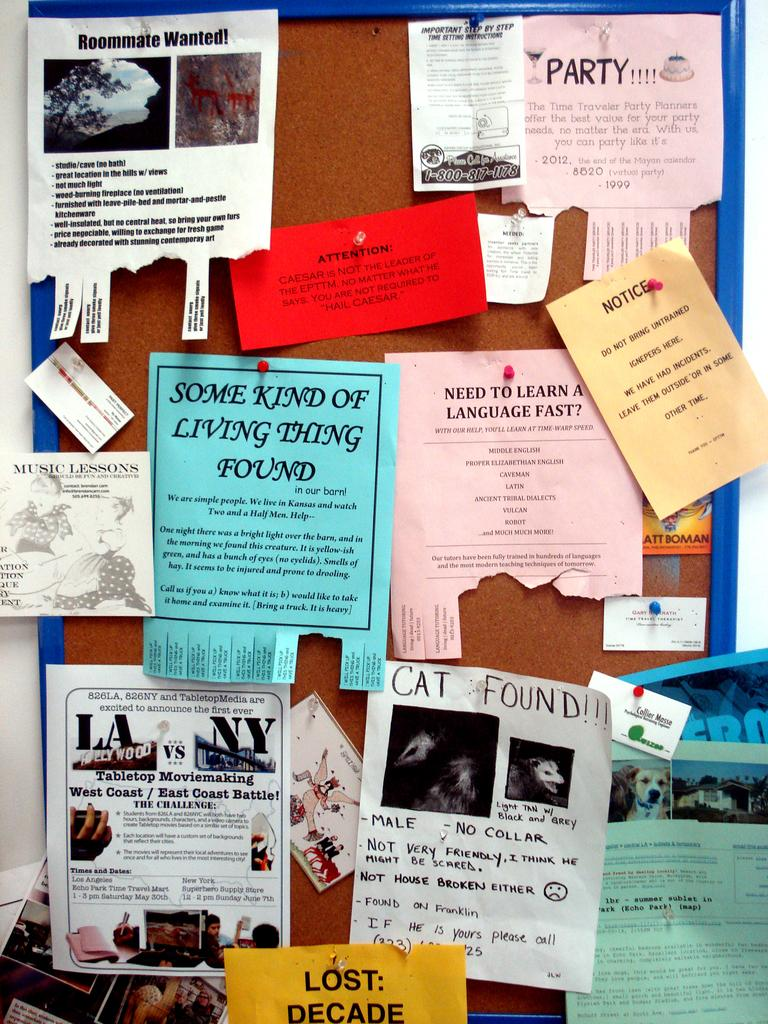<image>
Give a short and clear explanation of the subsequent image. Bulletin board with a paper that says "Some kind of living thing found". 